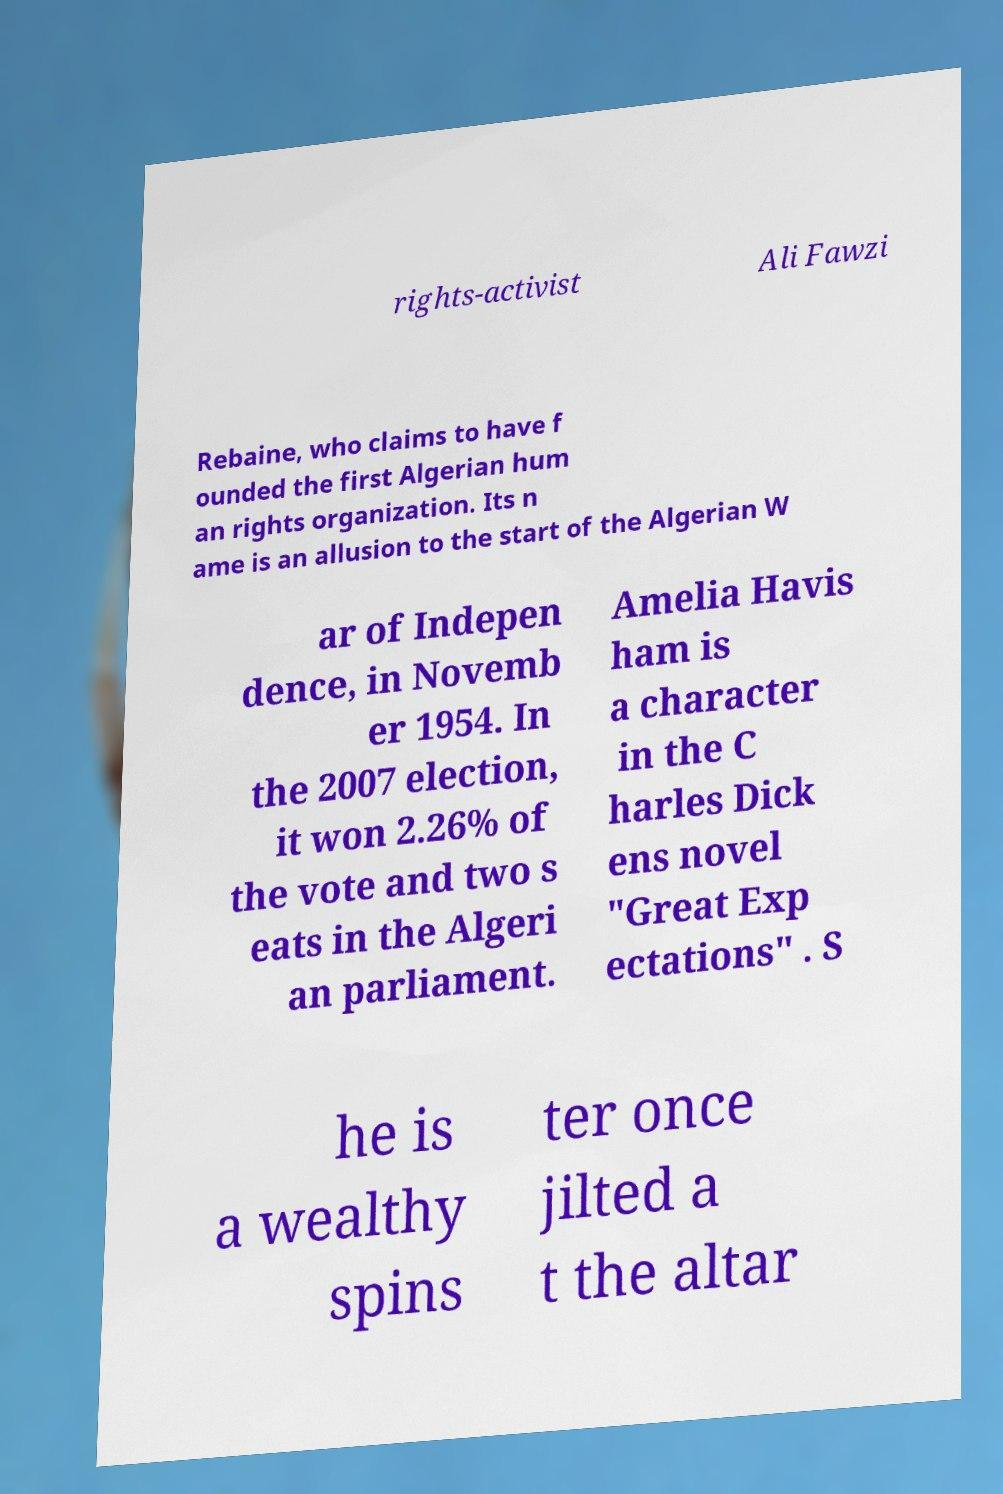There's text embedded in this image that I need extracted. Can you transcribe it verbatim? rights-activist Ali Fawzi Rebaine, who claims to have f ounded the first Algerian hum an rights organization. Its n ame is an allusion to the start of the Algerian W ar of Indepen dence, in Novemb er 1954. In the 2007 election, it won 2.26% of the vote and two s eats in the Algeri an parliament. Amelia Havis ham is a character in the C harles Dick ens novel "Great Exp ectations" . S he is a wealthy spins ter once jilted a t the altar 